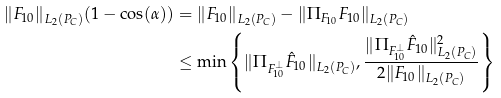<formula> <loc_0><loc_0><loc_500><loc_500>\| F _ { 1 0 } \| _ { L _ { 2 } ( P _ { C } ) } ( 1 - \cos ( \alpha ) ) & = \| F _ { 1 0 } \| _ { L _ { 2 } ( P _ { C } ) } - \| \Pi _ { F _ { 1 0 } } F _ { 1 0 } \| _ { L _ { 2 } ( P _ { C } ) } \\ & \leq \min \left \{ \| \Pi _ { F _ { 1 0 } ^ { \bot } } \hat { F } _ { 1 0 } \| _ { L _ { 2 } ( P _ { C } ) } , \frac { \| \Pi _ { F _ { 1 0 } ^ { \bot } } \hat { F } _ { 1 0 } \| ^ { 2 } _ { L _ { 2 } ( P _ { C } ) } } { 2 \| F _ { 1 0 } \| _ { L _ { 2 } ( P _ { C } ) } } \right \}</formula> 